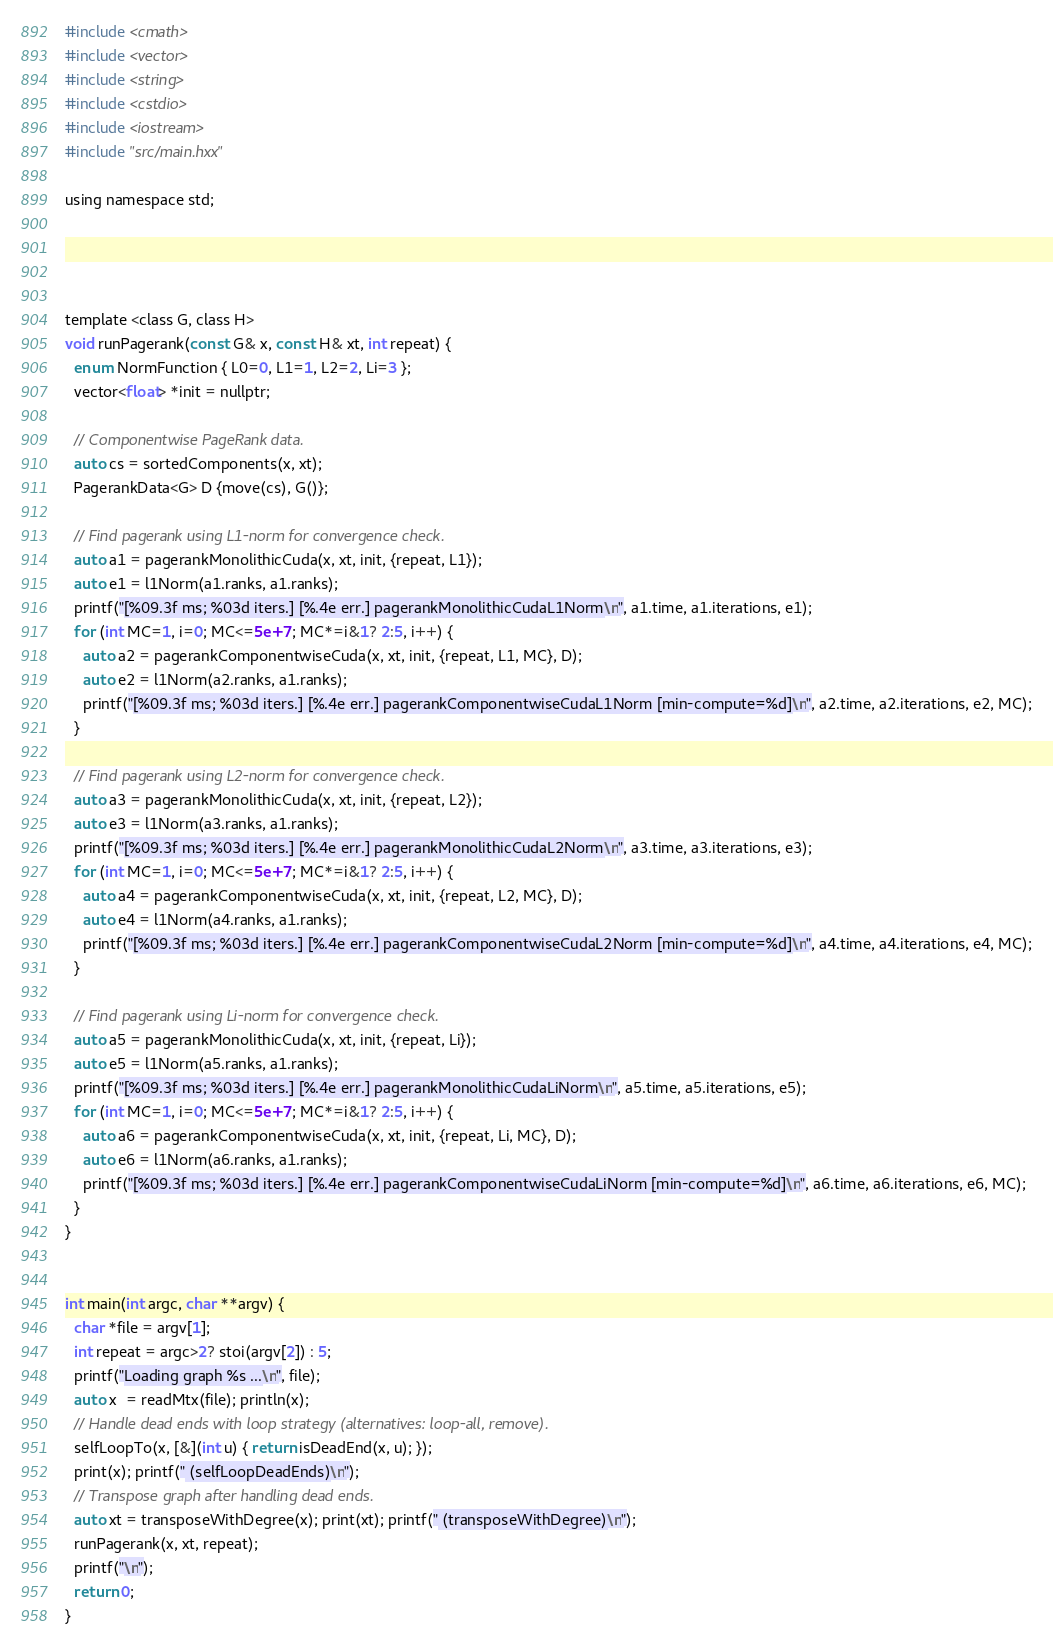Convert code to text. <code><loc_0><loc_0><loc_500><loc_500><_Cuda_>#include <cmath>
#include <vector>
#include <string>
#include <cstdio>
#include <iostream>
#include "src/main.hxx"

using namespace std;




template <class G, class H>
void runPagerank(const G& x, const H& xt, int repeat) {
  enum NormFunction { L0=0, L1=1, L2=2, Li=3 };
  vector<float> *init = nullptr;

  // Componentwise PageRank data.
  auto cs = sortedComponents(x, xt);
  PagerankData<G> D {move(cs), G()};

  // Find pagerank using L1-norm for convergence check.
  auto a1 = pagerankMonolithicCuda(x, xt, init, {repeat, L1});
  auto e1 = l1Norm(a1.ranks, a1.ranks);
  printf("[%09.3f ms; %03d iters.] [%.4e err.] pagerankMonolithicCudaL1Norm\n", a1.time, a1.iterations, e1);
  for (int MC=1, i=0; MC<=5e+7; MC*=i&1? 2:5, i++) {
    auto a2 = pagerankComponentwiseCuda(x, xt, init, {repeat, L1, MC}, D);
    auto e2 = l1Norm(a2.ranks, a1.ranks);
    printf("[%09.3f ms; %03d iters.] [%.4e err.] pagerankComponentwiseCudaL1Norm [min-compute=%d]\n", a2.time, a2.iterations, e2, MC);
  }

  // Find pagerank using L2-norm for convergence check.
  auto a3 = pagerankMonolithicCuda(x, xt, init, {repeat, L2});
  auto e3 = l1Norm(a3.ranks, a1.ranks);
  printf("[%09.3f ms; %03d iters.] [%.4e err.] pagerankMonolithicCudaL2Norm\n", a3.time, a3.iterations, e3);
  for (int MC=1, i=0; MC<=5e+7; MC*=i&1? 2:5, i++) {
    auto a4 = pagerankComponentwiseCuda(x, xt, init, {repeat, L2, MC}, D);
    auto e4 = l1Norm(a4.ranks, a1.ranks);
    printf("[%09.3f ms; %03d iters.] [%.4e err.] pagerankComponentwiseCudaL2Norm [min-compute=%d]\n", a4.time, a4.iterations, e4, MC);
  }

  // Find pagerank using Li-norm for convergence check.
  auto a5 = pagerankMonolithicCuda(x, xt, init, {repeat, Li});
  auto e5 = l1Norm(a5.ranks, a1.ranks);
  printf("[%09.3f ms; %03d iters.] [%.4e err.] pagerankMonolithicCudaLiNorm\n", a5.time, a5.iterations, e5);
  for (int MC=1, i=0; MC<=5e+7; MC*=i&1? 2:5, i++) {
    auto a6 = pagerankComponentwiseCuda(x, xt, init, {repeat, Li, MC}, D);
    auto e6 = l1Norm(a6.ranks, a1.ranks);
    printf("[%09.3f ms; %03d iters.] [%.4e err.] pagerankComponentwiseCudaLiNorm [min-compute=%d]\n", a6.time, a6.iterations, e6, MC);
  }
}


int main(int argc, char **argv) {
  char *file = argv[1];
  int repeat = argc>2? stoi(argv[2]) : 5;
  printf("Loading graph %s ...\n", file);
  auto x  = readMtx(file); println(x);
  // Handle dead ends with loop strategy (alternatives: loop-all, remove).
  selfLoopTo(x, [&](int u) { return isDeadEnd(x, u); });
  print(x); printf(" (selfLoopDeadEnds)\n");
  // Transpose graph after handling dead ends.
  auto xt = transposeWithDegree(x); print(xt); printf(" (transposeWithDegree)\n");
  runPagerank(x, xt, repeat);
  printf("\n");
  return 0;
}
</code> 